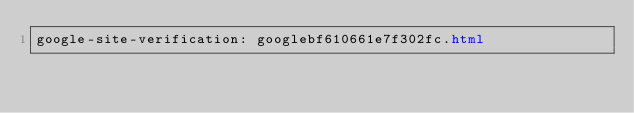<code> <loc_0><loc_0><loc_500><loc_500><_HTML_>google-site-verification: googlebf610661e7f302fc.html</code> 